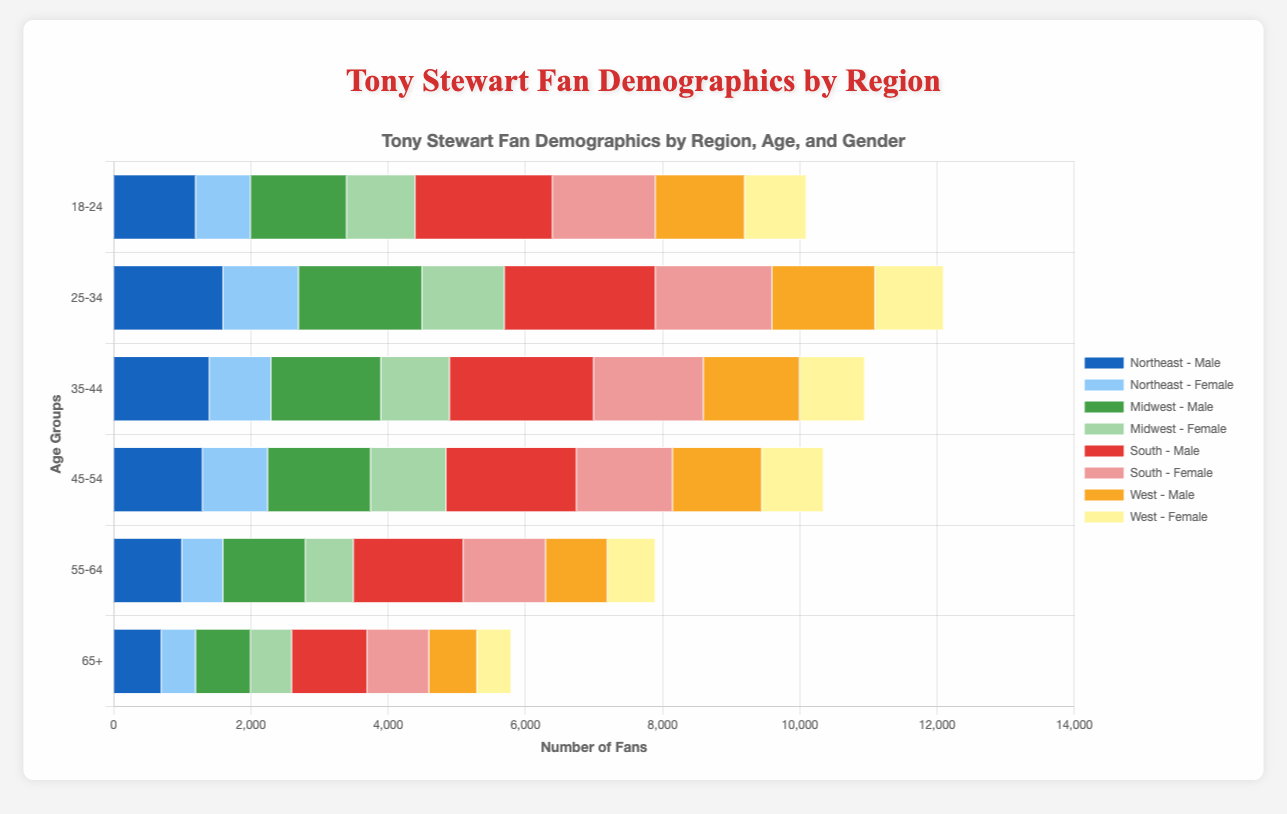Which region has the highest number of male fans in the 18-24 age group? The bars' lengths in the horizontal bar chart can be compared to determine the region with the highest number of male fans in the 18-24 age group. The South region bar is the longest for males in this age group, indicating the largest number of fans.
Answer: South How does the number of female fans in the 45-54 age group in the South compare to the Midwest? Compare the length of the relevant bars for female fans in the 45-54 age group between the South and Midwest. The South has a bar representing 1,400 fans, while the Midwest has a bar representing 1,100 fans.
Answer: The South has more female fans Calculate the total number of fans in the 25-34 age group in the Northeast. Sum the number of male and female fans in the 25-34 age group in the Northeast. (1,600 males + 1,100 females) = 2,700 fans.
Answer: 2,700 Which age group has the smallest number of male fans in the West? Compare the lengths of the bars for different age groups representing male fans in the West. The 65+ age group has the shortest bar, representing the smallest number.
Answer: 65+ What is the total number of female fans in the Midwest across all age groups? Sum the number of female fans from each age group in the Midwest: 1,000 + 1,200 + 1,000 + 1,100 + 700 + 600 = 5,600.
Answer: 5,600 In which region do female fans outnumber male fans the most in the 35-44 age group? Look for the biggest difference between female and male bars in the 35-44 age group across regions. In the South, females (1,600) outnumber males (2,100) the most, with a difference of 500 fans.
Answer: South What is the average number of fans in the 18-24 age group in the South? Calculate the average by summing the total number of fans in the 18-24 age group in the South (2,000 males + 1,500 females = 3,500) and dividing by 2.
Answer: 1,750 Which age group in the Midwest has more male than female fans by the largest margin? Compare the differences between male and female fans across age groups in the Midwest. The largest difference is in the 25-34 age group, with 1,800 males and 1,200 females, a difference of 600 fans.
Answer: 25-34 